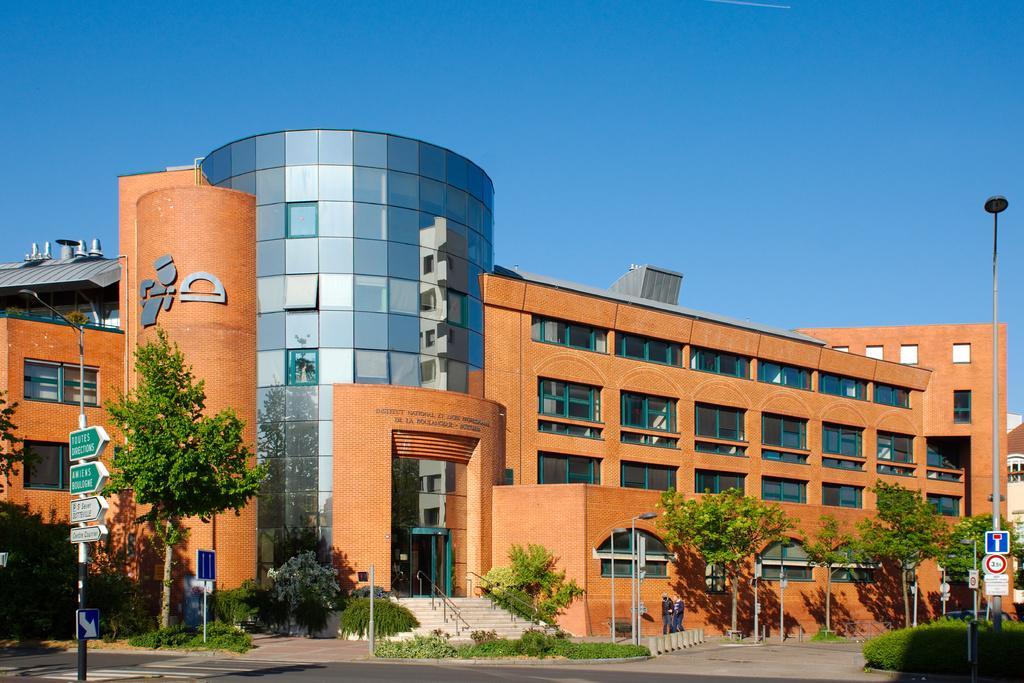In one or two sentences, can you explain what this image depicts? In this picture we can see a building here, there are some trees here, we can see stairs here, there is a pole and boards here, we can see the sky at the top of the picture, on the left side there are direction words, we can see bushes here. 